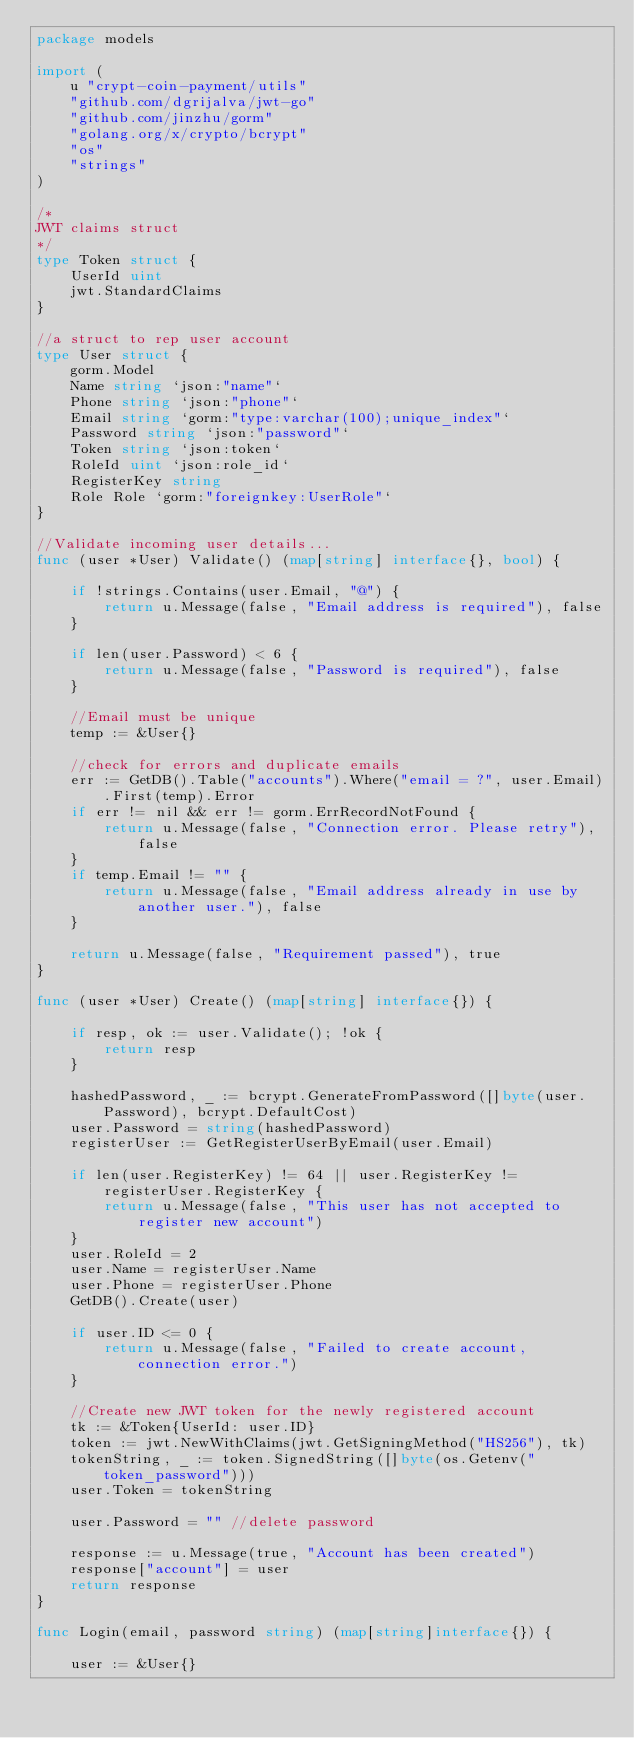Convert code to text. <code><loc_0><loc_0><loc_500><loc_500><_Go_>package models

import (
	u "crypt-coin-payment/utils"
	"github.com/dgrijalva/jwt-go"
	"github.com/jinzhu/gorm"
	"golang.org/x/crypto/bcrypt"
	"os"
	"strings"
)

/*
JWT claims struct
*/
type Token struct {
	UserId uint
	jwt.StandardClaims
}

//a struct to rep user account
type User struct {
	gorm.Model
	Name string `json:"name"`
	Phone string `json:"phone"`
	Email string `gorm:"type:varchar(100);unique_index"`
	Password string `json:"password"`
	Token string `json:token`
	RoleId uint `json:role_id`
	RegisterKey string
	Role Role `gorm:"foreignkey:UserRole"`
}

//Validate incoming user details...
func (user *User) Validate() (map[string] interface{}, bool) {

	if !strings.Contains(user.Email, "@") {
		return u.Message(false, "Email address is required"), false
	}

	if len(user.Password) < 6 {
		return u.Message(false, "Password is required"), false
	}

	//Email must be unique
	temp := &User{}

	//check for errors and duplicate emails
	err := GetDB().Table("accounts").Where("email = ?", user.Email).First(temp).Error
	if err != nil && err != gorm.ErrRecordNotFound {
		return u.Message(false, "Connection error. Please retry"), false
	}
	if temp.Email != "" {
		return u.Message(false, "Email address already in use by another user."), false
	}

	return u.Message(false, "Requirement passed"), true
}

func (user *User) Create() (map[string] interface{}) {

	if resp, ok := user.Validate(); !ok {
		return resp
	}

	hashedPassword, _ := bcrypt.GenerateFromPassword([]byte(user.Password), bcrypt.DefaultCost)
	user.Password = string(hashedPassword)
	registerUser := GetRegisterUserByEmail(user.Email)

	if len(user.RegisterKey) != 64 || user.RegisterKey != registerUser.RegisterKey {
		return u.Message(false, "This user has not accepted to register new account")
	}
	user.RoleId = 2
	user.Name = registerUser.Name
	user.Phone = registerUser.Phone
	GetDB().Create(user)

	if user.ID <= 0 {
		return u.Message(false, "Failed to create account, connection error.")
	}

	//Create new JWT token for the newly registered account
	tk := &Token{UserId: user.ID}
	token := jwt.NewWithClaims(jwt.GetSigningMethod("HS256"), tk)
	tokenString, _ := token.SignedString([]byte(os.Getenv("token_password")))
	user.Token = tokenString

	user.Password = "" //delete password

	response := u.Message(true, "Account has been created")
	response["account"] = user
	return response
}

func Login(email, password string) (map[string]interface{}) {

	user := &User{}</code> 